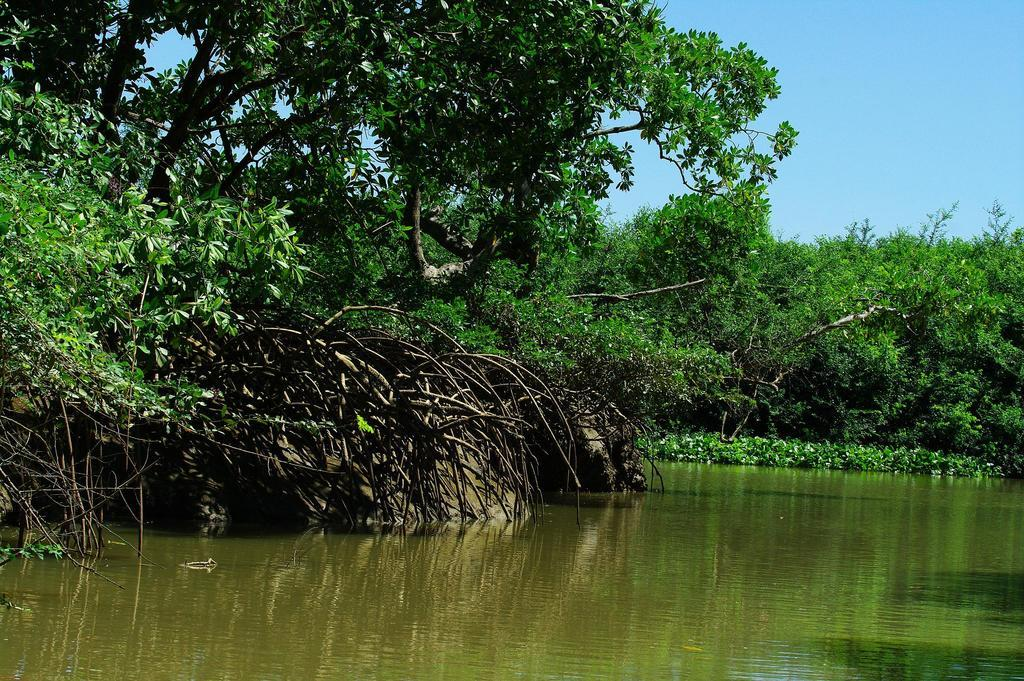What is the primary element visible in the image? There is water in the image. What type of vegetation can be seen in the image? There are trees and plants in the image. What part of the natural environment is visible in the background of the image? The sky is visible in the background of the image. What type of badge is being worn by the water in the image? There is no badge present in the image, as the primary element is water. 